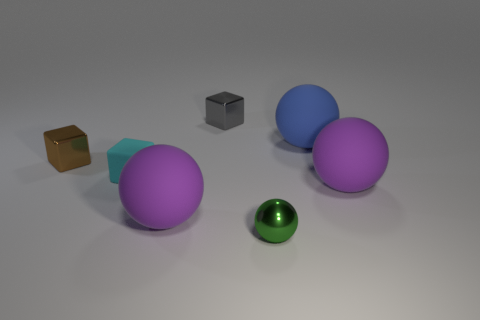What is the material of the cyan thing?
Keep it short and to the point. Rubber. Are there more tiny things that are behind the small green metallic ball than brown cubes?
Provide a short and direct response. Yes. There is a small cube that is behind the metal cube in front of the gray shiny cube; what number of gray things are behind it?
Your answer should be compact. 0. What is the small object that is right of the small cyan object and in front of the tiny brown block made of?
Give a very brief answer. Metal. The metal sphere has what color?
Your answer should be very brief. Green. Is the number of small things in front of the tiny brown metal object greater than the number of green shiny balls right of the green shiny thing?
Give a very brief answer. Yes. What color is the metallic object to the left of the rubber cube?
Provide a succinct answer. Brown. Do the shiny block that is on the right side of the tiny brown shiny cube and the blue ball that is right of the rubber block have the same size?
Offer a terse response. No. How many objects are either small red cubes or green metal objects?
Your answer should be very brief. 1. What is the purple ball that is in front of the purple rubber ball that is on the right side of the shiny ball made of?
Offer a terse response. Rubber. 